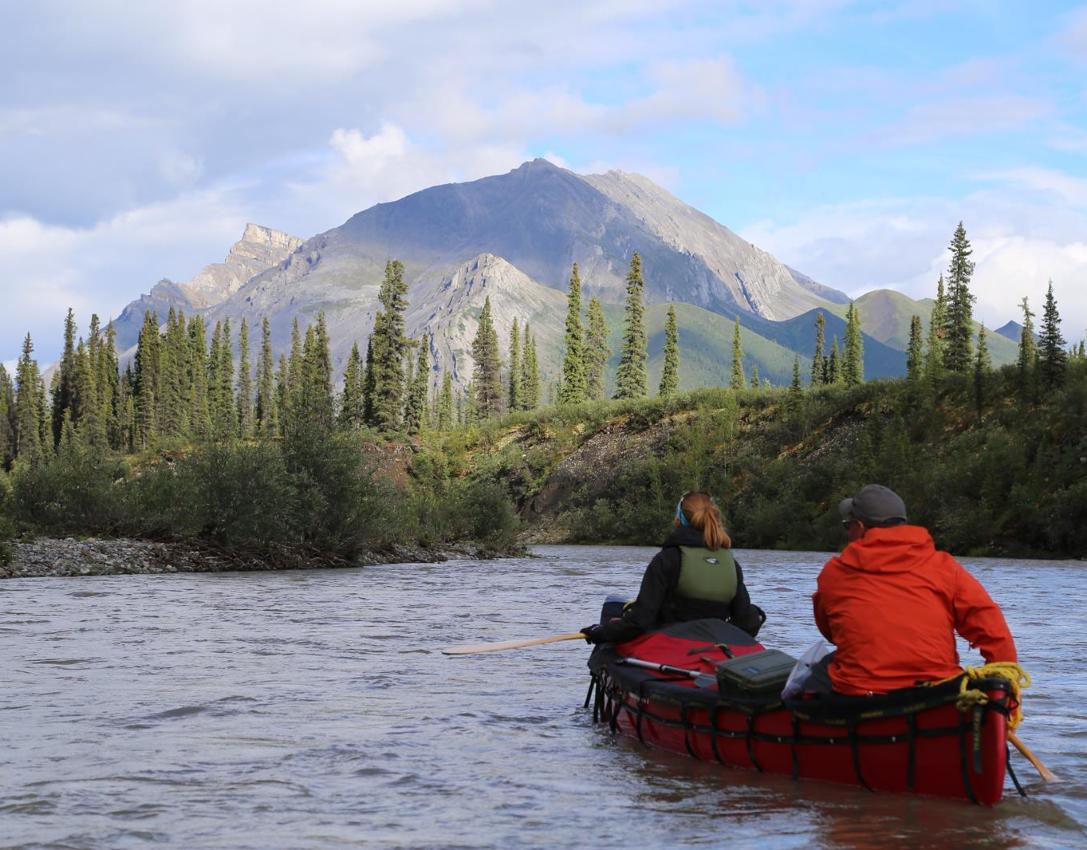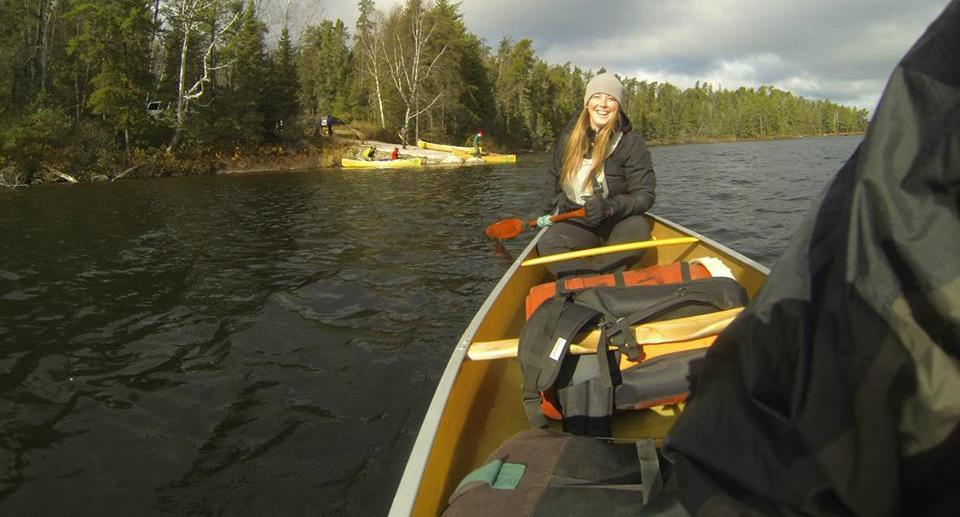The first image is the image on the left, the second image is the image on the right. Considering the images on both sides, is "There are exactly two canoes in the water." valid? Answer yes or no. Yes. The first image is the image on the left, the second image is the image on the right. For the images shown, is this caption "The left and right image contains the same number of boats facing left and forward." true? Answer yes or no. No. 